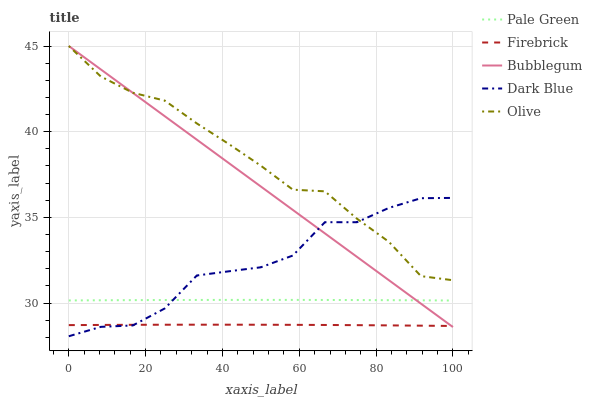Does Firebrick have the minimum area under the curve?
Answer yes or no. Yes. Does Olive have the maximum area under the curve?
Answer yes or no. Yes. Does Dark Blue have the minimum area under the curve?
Answer yes or no. No. Does Dark Blue have the maximum area under the curve?
Answer yes or no. No. Is Bubblegum the smoothest?
Answer yes or no. Yes. Is Dark Blue the roughest?
Answer yes or no. Yes. Is Firebrick the smoothest?
Answer yes or no. No. Is Firebrick the roughest?
Answer yes or no. No. Does Dark Blue have the lowest value?
Answer yes or no. Yes. Does Firebrick have the lowest value?
Answer yes or no. No. Does Bubblegum have the highest value?
Answer yes or no. Yes. Does Dark Blue have the highest value?
Answer yes or no. No. Is Pale Green less than Olive?
Answer yes or no. Yes. Is Pale Green greater than Firebrick?
Answer yes or no. Yes. Does Dark Blue intersect Bubblegum?
Answer yes or no. Yes. Is Dark Blue less than Bubblegum?
Answer yes or no. No. Is Dark Blue greater than Bubblegum?
Answer yes or no. No. Does Pale Green intersect Olive?
Answer yes or no. No. 